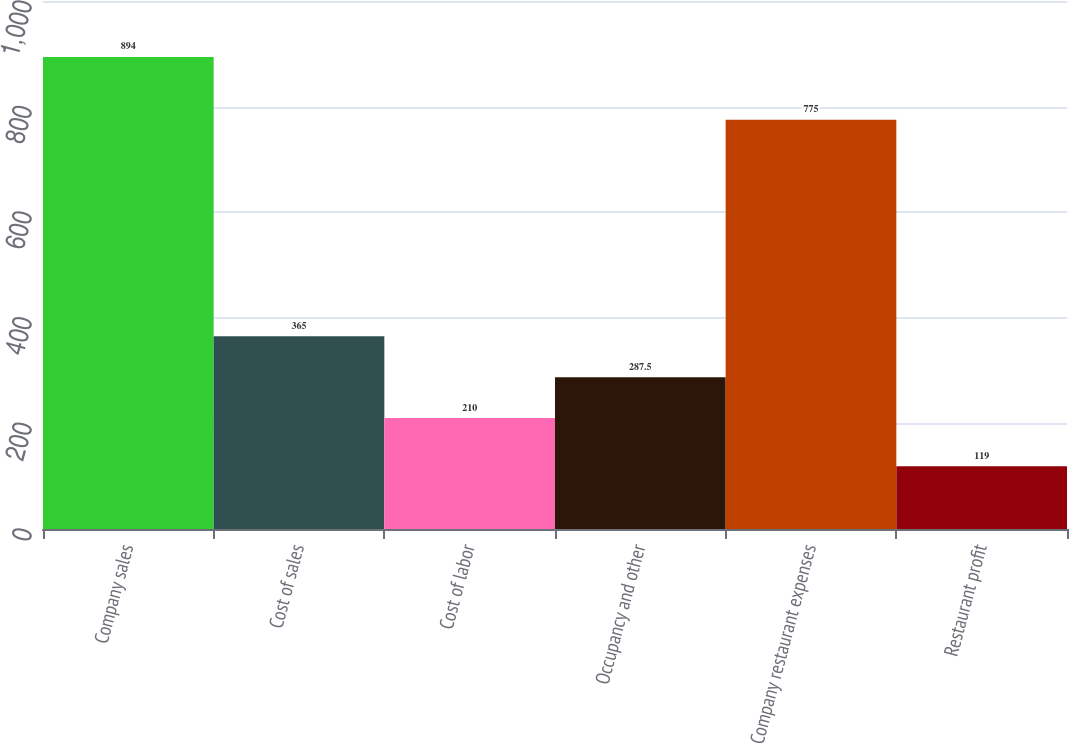Convert chart. <chart><loc_0><loc_0><loc_500><loc_500><bar_chart><fcel>Company sales<fcel>Cost of sales<fcel>Cost of labor<fcel>Occupancy and other<fcel>Company restaurant expenses<fcel>Restaurant profit<nl><fcel>894<fcel>365<fcel>210<fcel>287.5<fcel>775<fcel>119<nl></chart> 